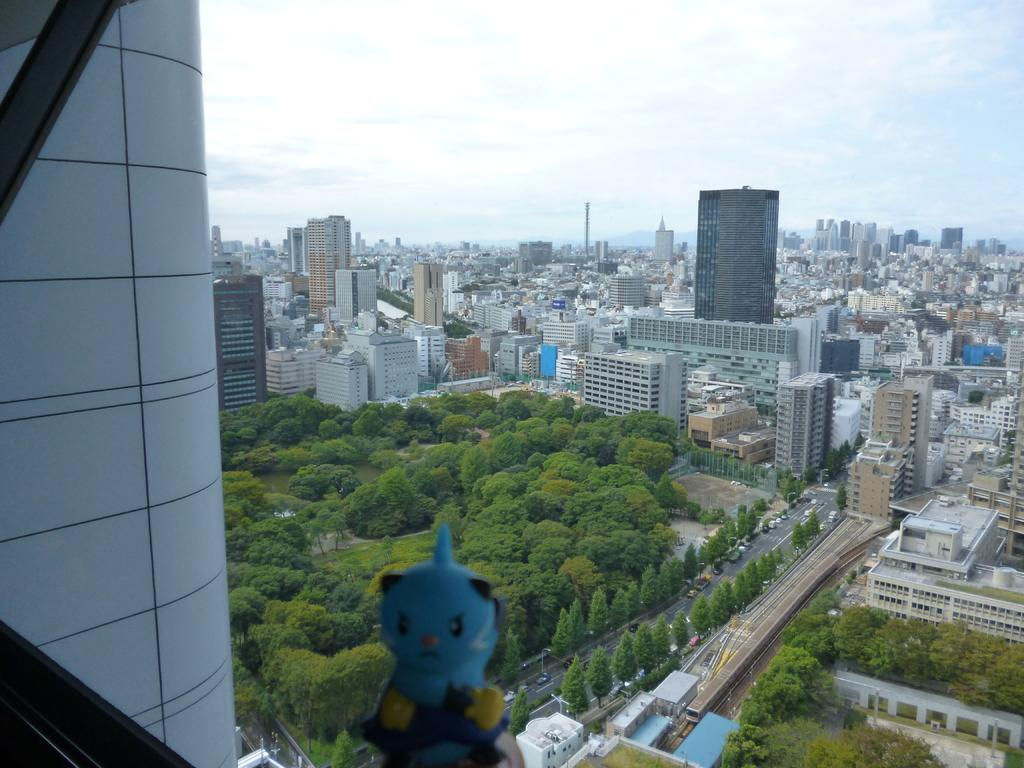What type of structures can be seen in the image? There are buildings in the image. What other natural elements are present in the image? There are trees in the image. What type of man-made paths are visible in the image? There are roads in the image. What type of transportation can be seen in the image? There are vehicles in the image. What type of object might be used for play in the image? There is a toy in the image. What type of fragile objects are present in the image? There are glass objects in the image. What is visible at the top of the image? The sky is visible at the top of the image. How many cows are lying on the beds in the image? There are no cows or beds present in the image. What type of station is visible in the image? There is no station present in the image. 